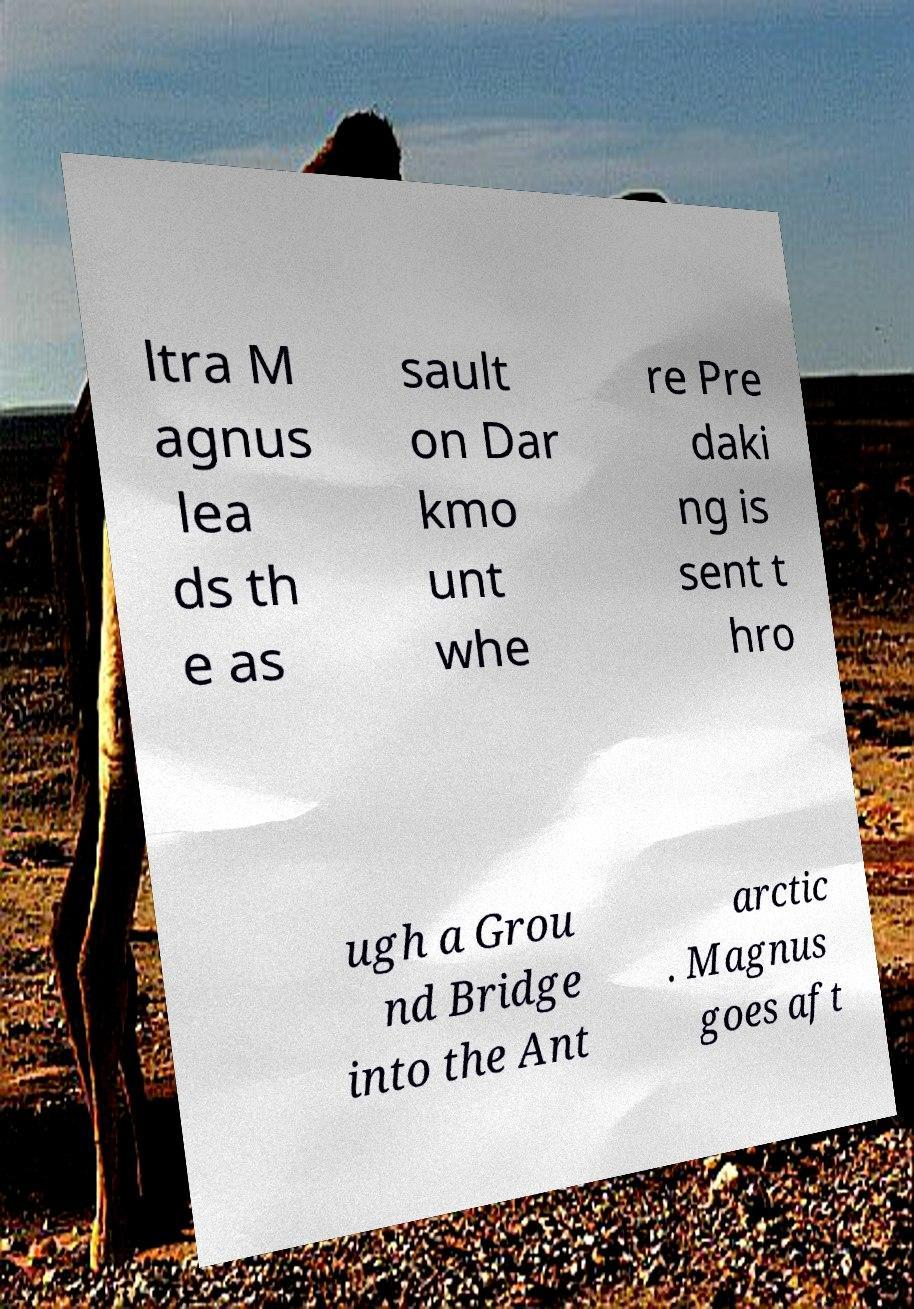Could you extract and type out the text from this image? ltra M agnus lea ds th e as sault on Dar kmo unt whe re Pre daki ng is sent t hro ugh a Grou nd Bridge into the Ant arctic . Magnus goes aft 